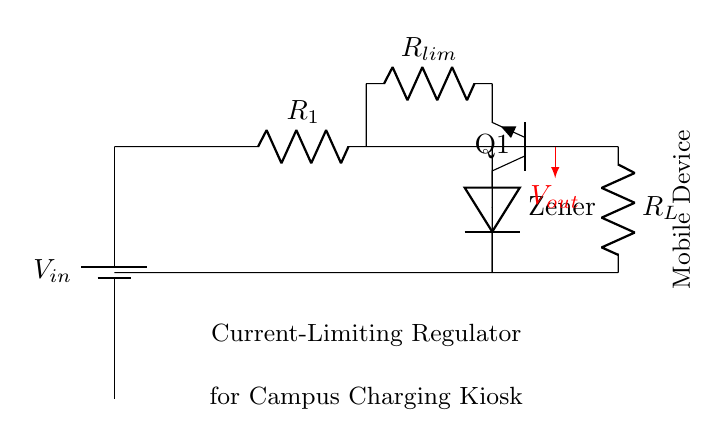What is the input voltage in this circuit? The input voltage, labeled as V in, is connected to the battery symbol, indicating the power supply for the circuit.
Answer: V in What type of voltage regulator is used here? The circuit contains a Zener diode, which is used for voltage regulation, specifically for providing a stable output voltage despite variations in input voltage.
Answer: Zener How many resistors are in the circuit? The circuit features two resistors, R1 and R limiting. R1 is in series with the Zener diode, while R limiting is in series with the transistor.
Answer: Two What is the purpose of the current-limiting resistor? The current-limiting resistor, which is R limiting in the circuit, is designed to protect the downstream components from excessive current by limiting the maximum current that can flow through the circuit.
Answer: Protects against excessive current What happens to the output voltage when the load resistance decreases? When load resistance, R L, decreases, more current will flow through the circuit. The regulator will compensate to maintain a constant output voltage until the limit is reached, after which the regulation may fail, leading to a drop in output voltage.
Answer: Output voltage may drop 